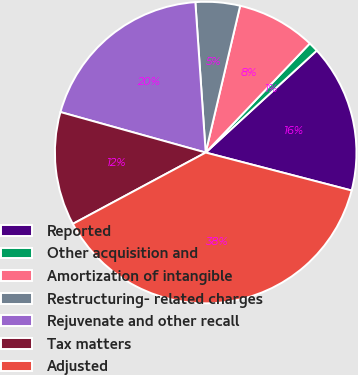<chart> <loc_0><loc_0><loc_500><loc_500><pie_chart><fcel>Reported<fcel>Other acquisition and<fcel>Amortization of intangible<fcel>Restructuring- related charges<fcel>Rejuvenate and other recall<fcel>Tax matters<fcel>Adjusted<nl><fcel>15.87%<fcel>1.05%<fcel>8.46%<fcel>4.76%<fcel>19.58%<fcel>12.17%<fcel>38.11%<nl></chart> 